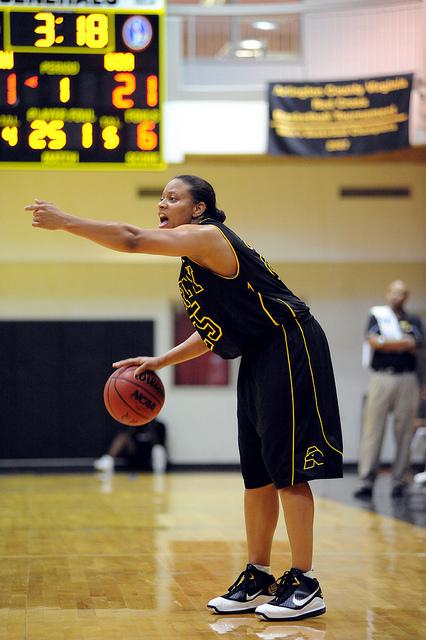How many minutes left to play?
Concise answer only. 3:18. What is the brand name of her shoes?
Answer briefly. Nike. Is this a professional game?
Answer briefly. Yes. Is the sport being shown in the major leagues?
Answer briefly. No. 